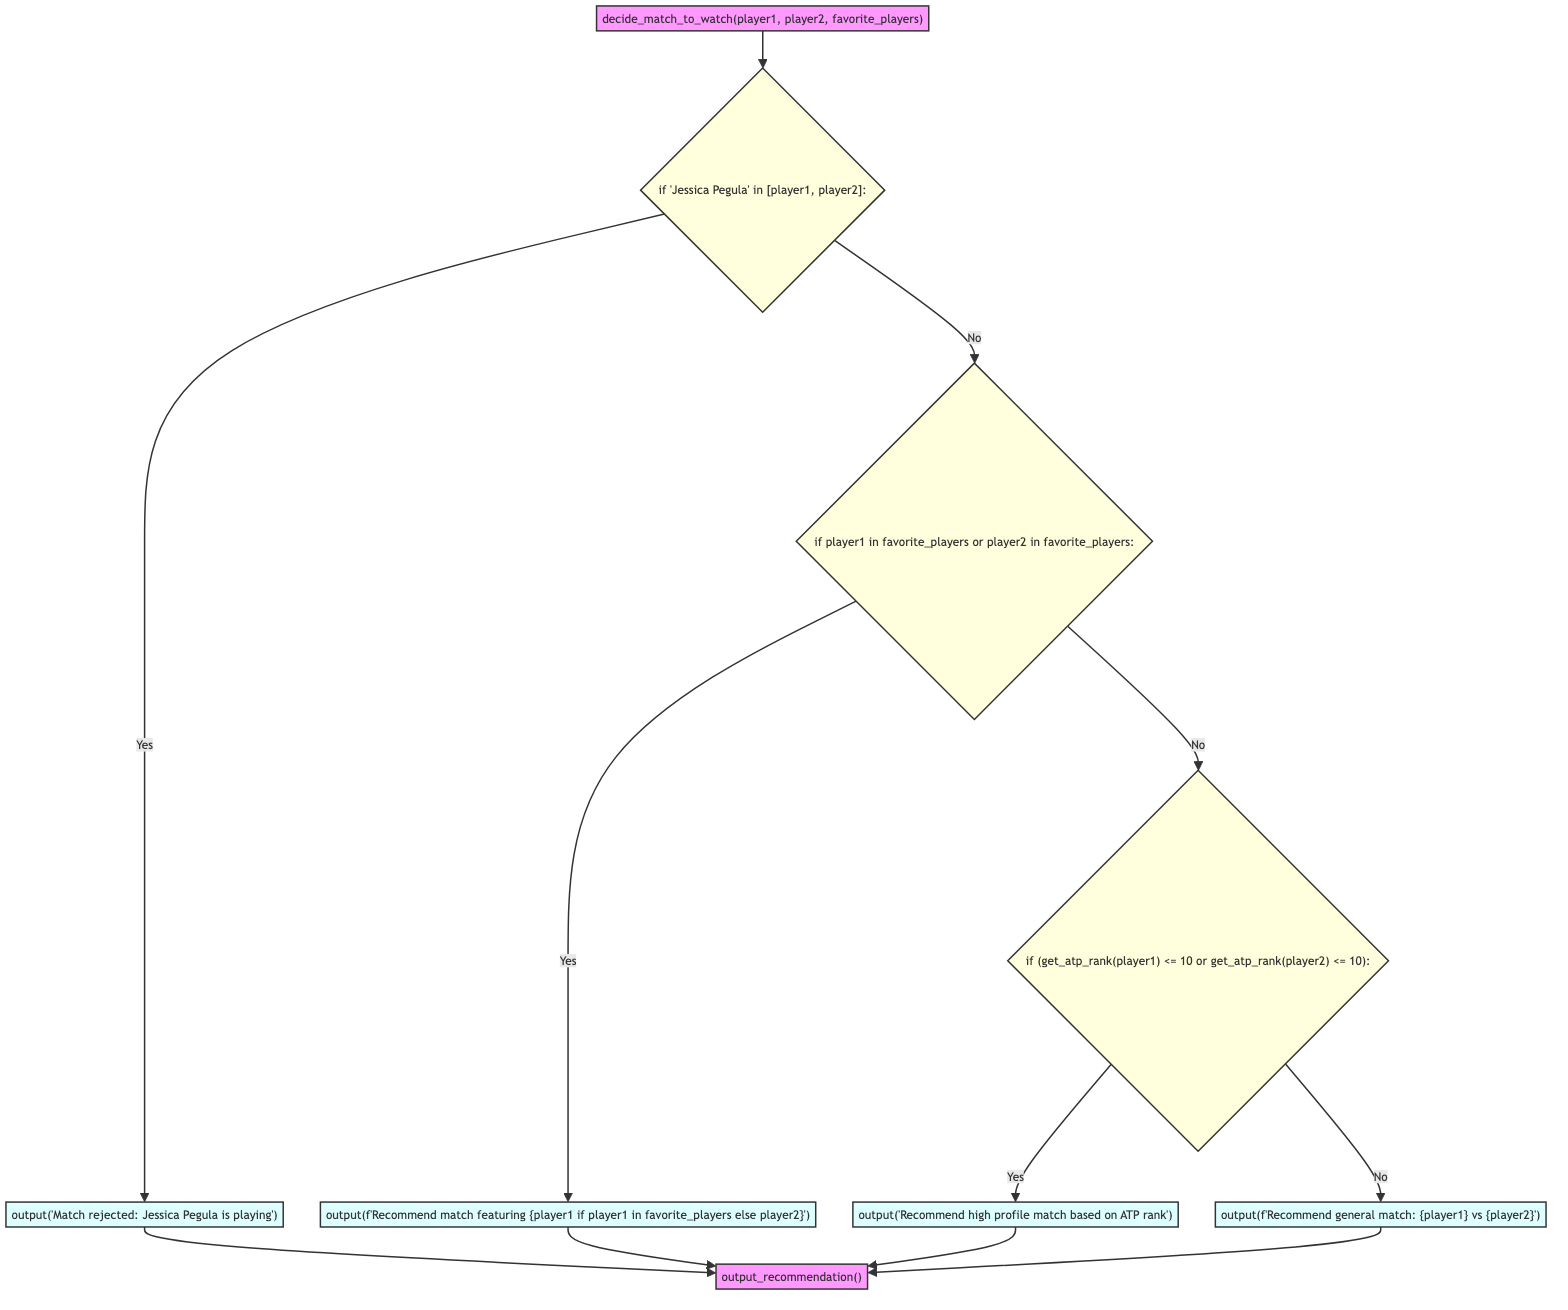What is the first step in the flowchart? The first step in the flowchart is the initial function call that evaluates the match by passing player1, player2, and favorite players to the function. This is represented by the node labeled "Initial Function Call".
Answer: Initial Function Call What happens if either player is Jessica Pegula? If either player is Jessica Pegula, the flowchart directs to the "Reject Match" node, where the action output is "Match rejected: Jessica Pegula is playing".
Answer: Reject Match How many main decision points are in the flowchart? The flowchart has three main decision points: checking for Jessica Pegula, checking for favorite players, and checking ATP rank, leading to various outcomes.
Answer: Three What is the action taken if any player is a favorite player? If any player is a favorite player, the action taken is to output a recommendation for the match featuring that player. This is shown in the node labeled "Recommend Player Match".
Answer: Recommend Player Match Which node follows the "Check ATP Rank" decision point if neither player is in the top 10? If neither player is in the top 10, the flowchart leads to the node labeled "Recommend General Match", where the match is recommended based on general criteria.
Answer: Recommend General Match What is the outcome of the flowchart after executing any recommendation action? After executing any recommendation action, the flowchart moves to the final output step, denoted by "Output", which indicates a conclusion has been reached and results are presented.
Answer: Output What condition leads to recommending a high-profile match based on ATP rank? The condition that leads to recommending a high-profile match is that at least one player's ATP rank is equal to or less than 10. This is evaluated in the "Check ATP Rank" decision node.
Answer: At least one player's ATP rank <= 10 What is the last node before returning to the output recommendation? The last node before returning to the output recommendation is either of the recommendation nodes—either "Recommend Player Match", "Recommend ATP High Rank Match", or "Recommend General Match", depending on the conditions met.
Answer: Recommend Player Match / Recommend ATP High Rank Match / Recommend General Match 